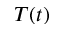<formula> <loc_0><loc_0><loc_500><loc_500>T ( t )</formula> 